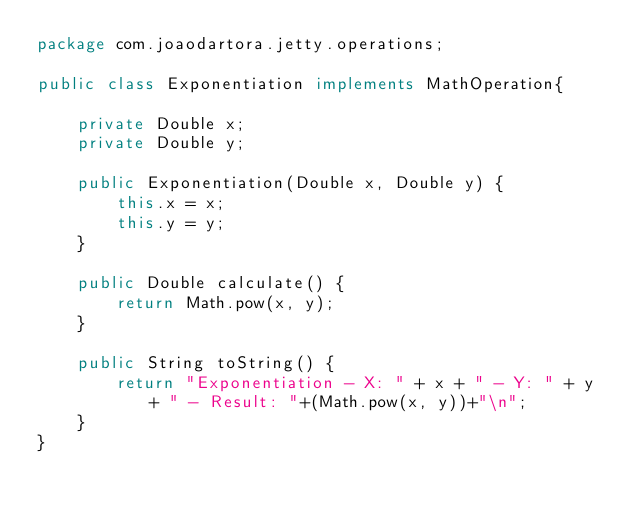<code> <loc_0><loc_0><loc_500><loc_500><_Java_>package com.joaodartora.jetty.operations;

public class Exponentiation implements MathOperation{

	private Double x;
	private Double y;
	
	public Exponentiation(Double x, Double y) {
		this.x = x;
		this.y = y;
	}

	public Double calculate() {
		return Math.pow(x, y);
	}
	
	public String toString() {
		return "Exponentiation - X: " + x + " - Y: " + y + " - Result: "+(Math.pow(x, y))+"\n";
	}
}
</code> 